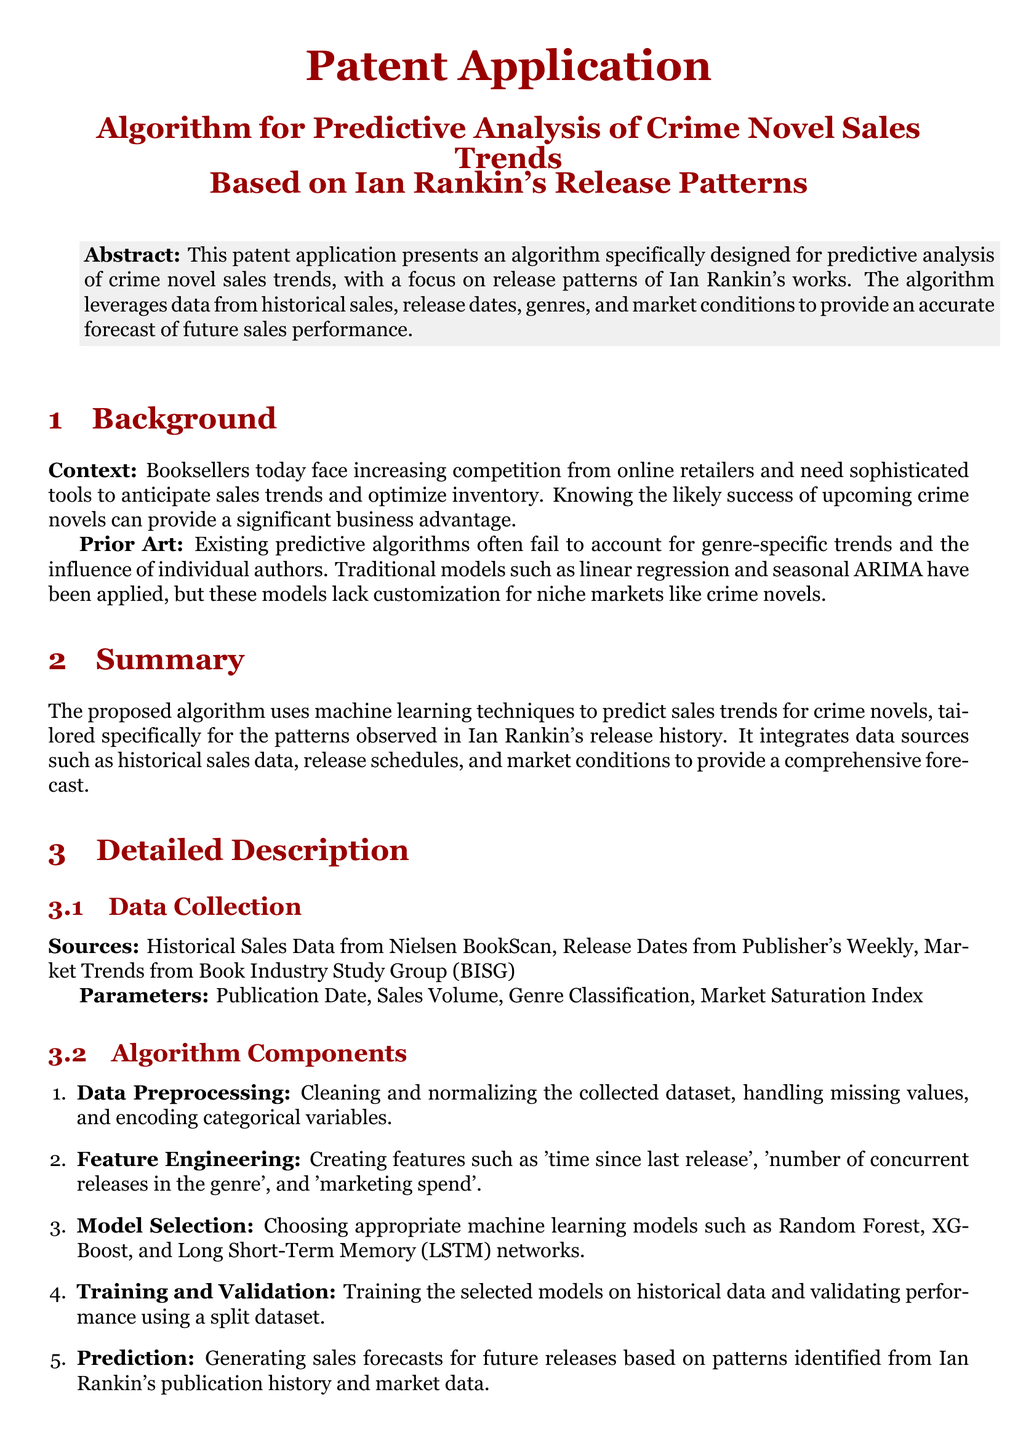What is the title of the patent application? The title is the main descriptive name of the patent application found at the top section of the document.
Answer: Algorithm for Predictive Analysis of Crime Novel Sales Trends Based on Ian Rankin's Release Patterns What is the primary focus of the algorithm? The primary focus of the algorithm is stated in the abstract section, highlighting its purpose.
Answer: Predictive analysis of crime novel sales trends What is the context for needing the algorithm? The context explains the current challenges faced by booksellers and their competition in the industry.
Answer: Increasing competition from online retailers What machine learning models does the algorithm utilize? This information is in the claims section detailing the types of models integrated into the algorithm.
Answer: Random Forest and LSTM networks What data source is mentioned for market trends? This question refers to the specific sources listed under the data collection section of the document.
Answer: Book Industry Study Group (BISG) What is the primary programming platform for the implementation? The implementation section specifies the platform used for developing the algorithm.
Answer: Python How many claims does the algorithm have? The claims section lists the assertions made about the algorithm, indicating the total number.
Answer: Four What parameter is used for feature engineering related to book releases? The detailed description section under "Feature Engineering" outlines specific features created for analysis.
Answer: Time since last release What aspect does the algorithm aim to improve for booksellers? The claims section suggests the benefit that booksellers would gain from using the algorithm.
Answer: Optimize inventory and marketing strategies 